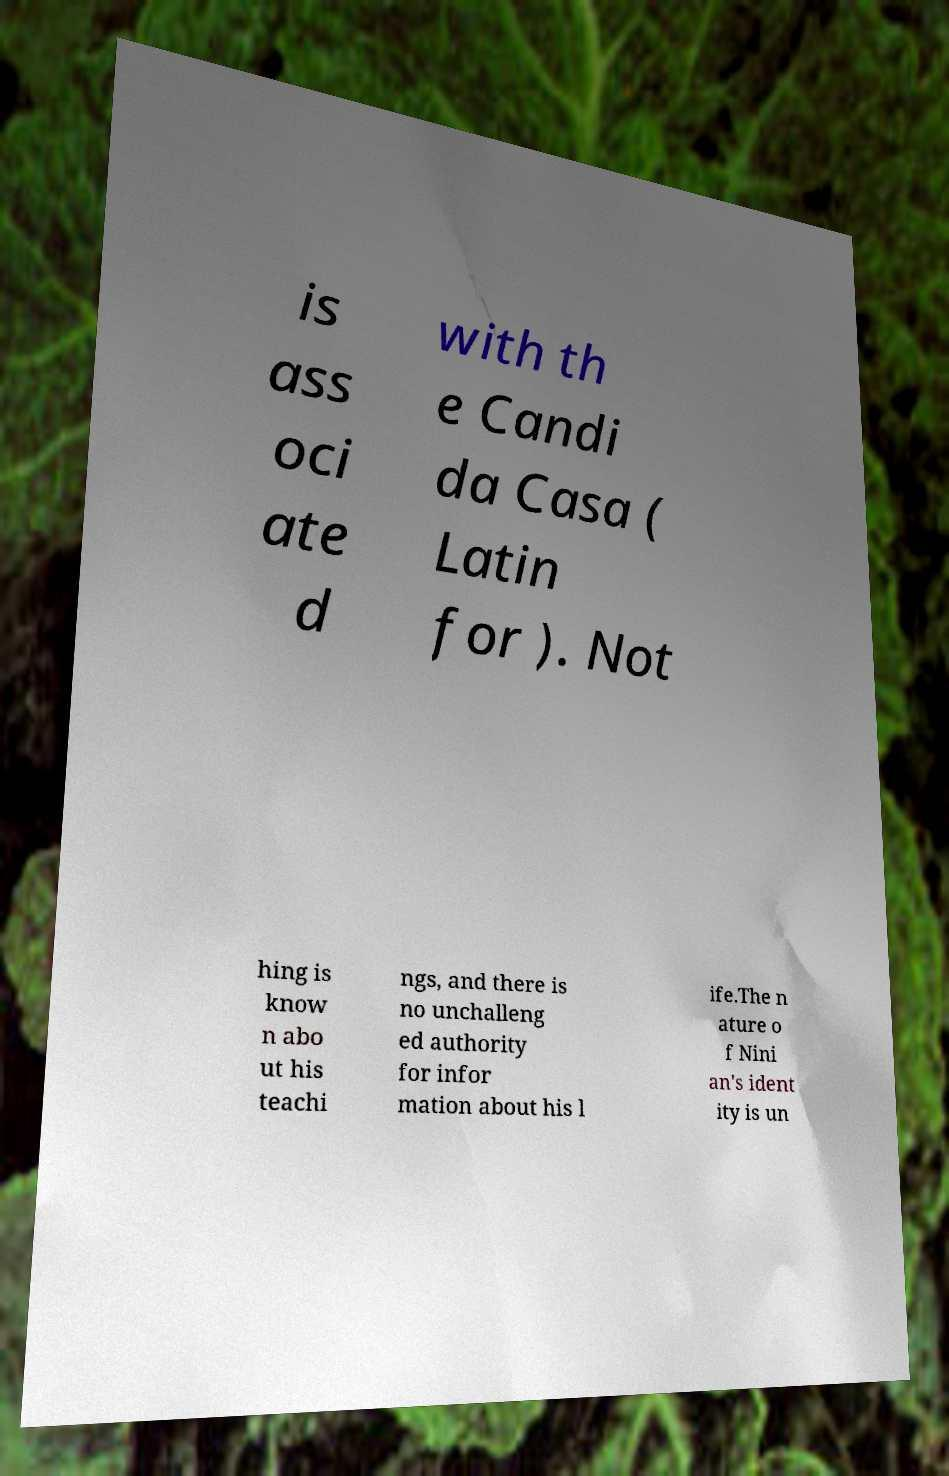Could you assist in decoding the text presented in this image and type it out clearly? is ass oci ate d with th e Candi da Casa ( Latin for ). Not hing is know n abo ut his teachi ngs, and there is no unchalleng ed authority for infor mation about his l ife.The n ature o f Nini an's ident ity is un 